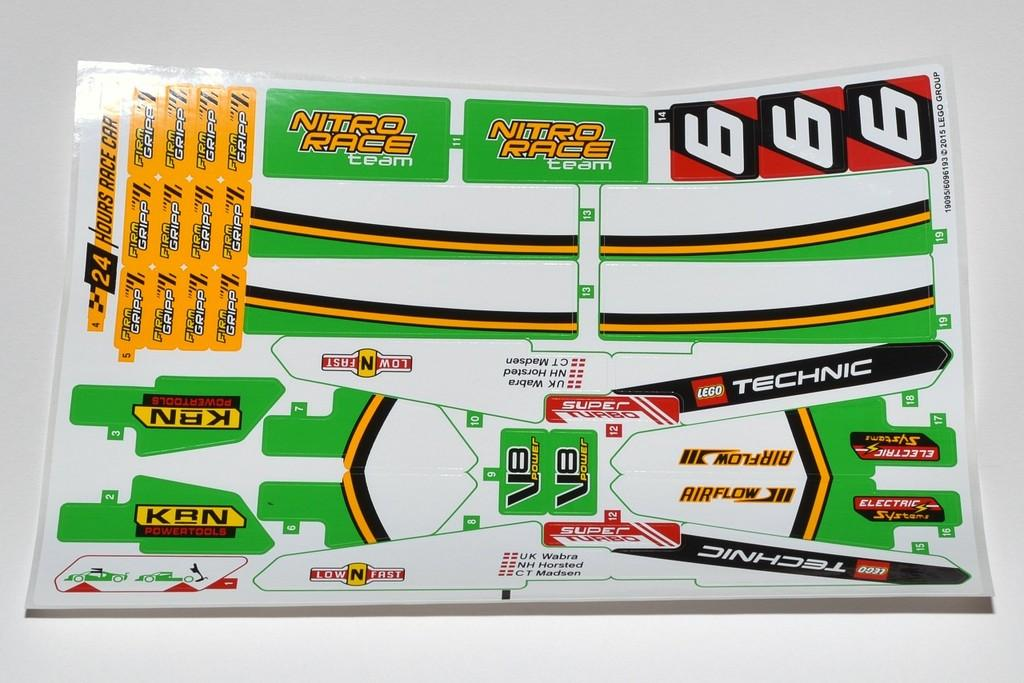<image>
Render a clear and concise summary of the photo. Race theme stickers with one reading "Nitro Race team". 